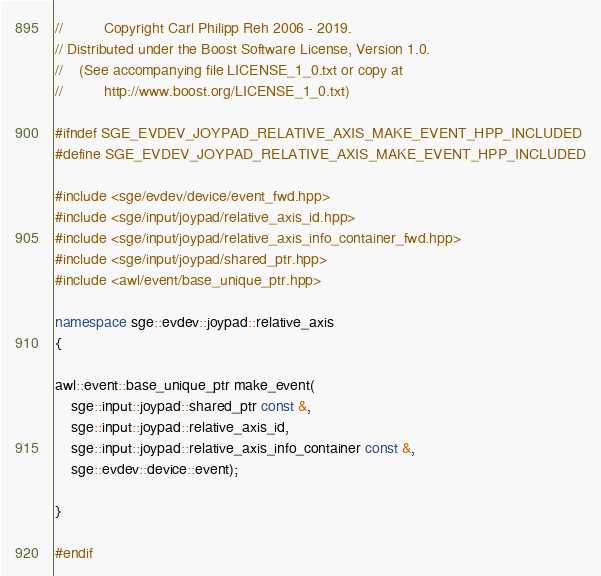Convert code to text. <code><loc_0><loc_0><loc_500><loc_500><_C++_>//          Copyright Carl Philipp Reh 2006 - 2019.
// Distributed under the Boost Software License, Version 1.0.
//    (See accompanying file LICENSE_1_0.txt or copy at
//          http://www.boost.org/LICENSE_1_0.txt)

#ifndef SGE_EVDEV_JOYPAD_RELATIVE_AXIS_MAKE_EVENT_HPP_INCLUDED
#define SGE_EVDEV_JOYPAD_RELATIVE_AXIS_MAKE_EVENT_HPP_INCLUDED

#include <sge/evdev/device/event_fwd.hpp>
#include <sge/input/joypad/relative_axis_id.hpp>
#include <sge/input/joypad/relative_axis_info_container_fwd.hpp>
#include <sge/input/joypad/shared_ptr.hpp>
#include <awl/event/base_unique_ptr.hpp>

namespace sge::evdev::joypad::relative_axis
{

awl::event::base_unique_ptr make_event(
    sge::input::joypad::shared_ptr const &,
    sge::input::joypad::relative_axis_id,
    sge::input::joypad::relative_axis_info_container const &,
    sge::evdev::device::event);

}

#endif
</code> 